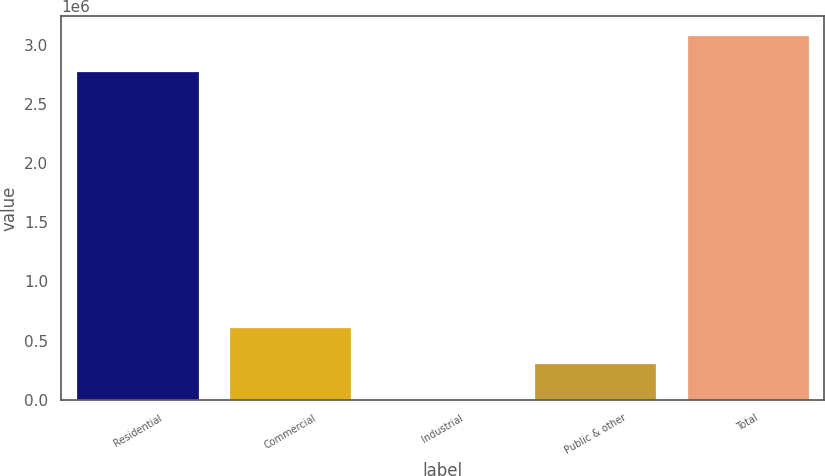Convert chart. <chart><loc_0><loc_0><loc_500><loc_500><bar_chart><fcel>Residential<fcel>Commercial<fcel>Industrial<fcel>Public & other<fcel>Total<nl><fcel>2.78335e+06<fcel>614503<fcel>3894<fcel>309198<fcel>3.08866e+06<nl></chart> 